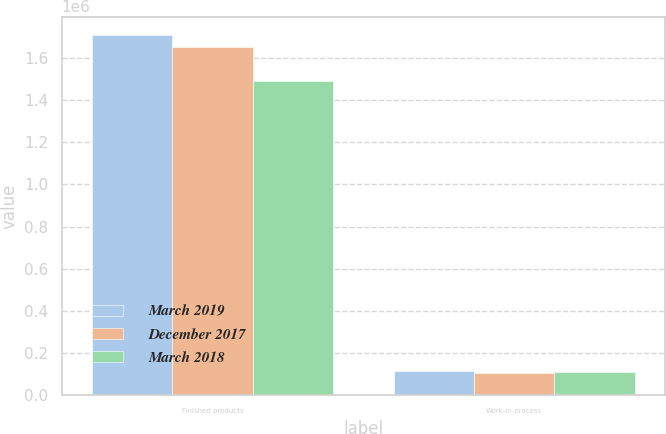Convert chart. <chart><loc_0><loc_0><loc_500><loc_500><stacked_bar_chart><ecel><fcel>Finished products<fcel>Work-in-process<nl><fcel>March 2019<fcel>1.71126e+06<fcel>114356<nl><fcel>December 2017<fcel>1.65414e+06<fcel>103757<nl><fcel>March 2018<fcel>1.49079e+06<fcel>110467<nl></chart> 